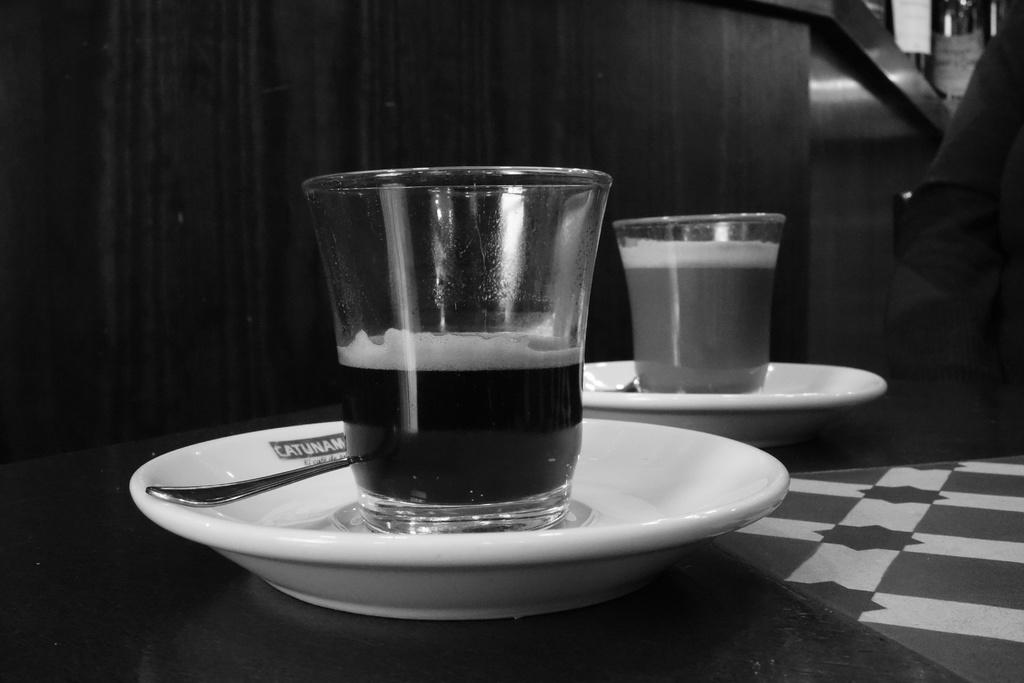What is the color scheme of the image? The image is black and white. How many plates are visible in the image? There are two plates in the image. What utensils are present in the image? There are spoons in the image. What type of dishware is also visible in the image? There are cups in the image. Are there any bears visible in the image? No, there are no bears present in the image. What type of calculator can be seen on the table in the image? There is no calculator present in the image. 